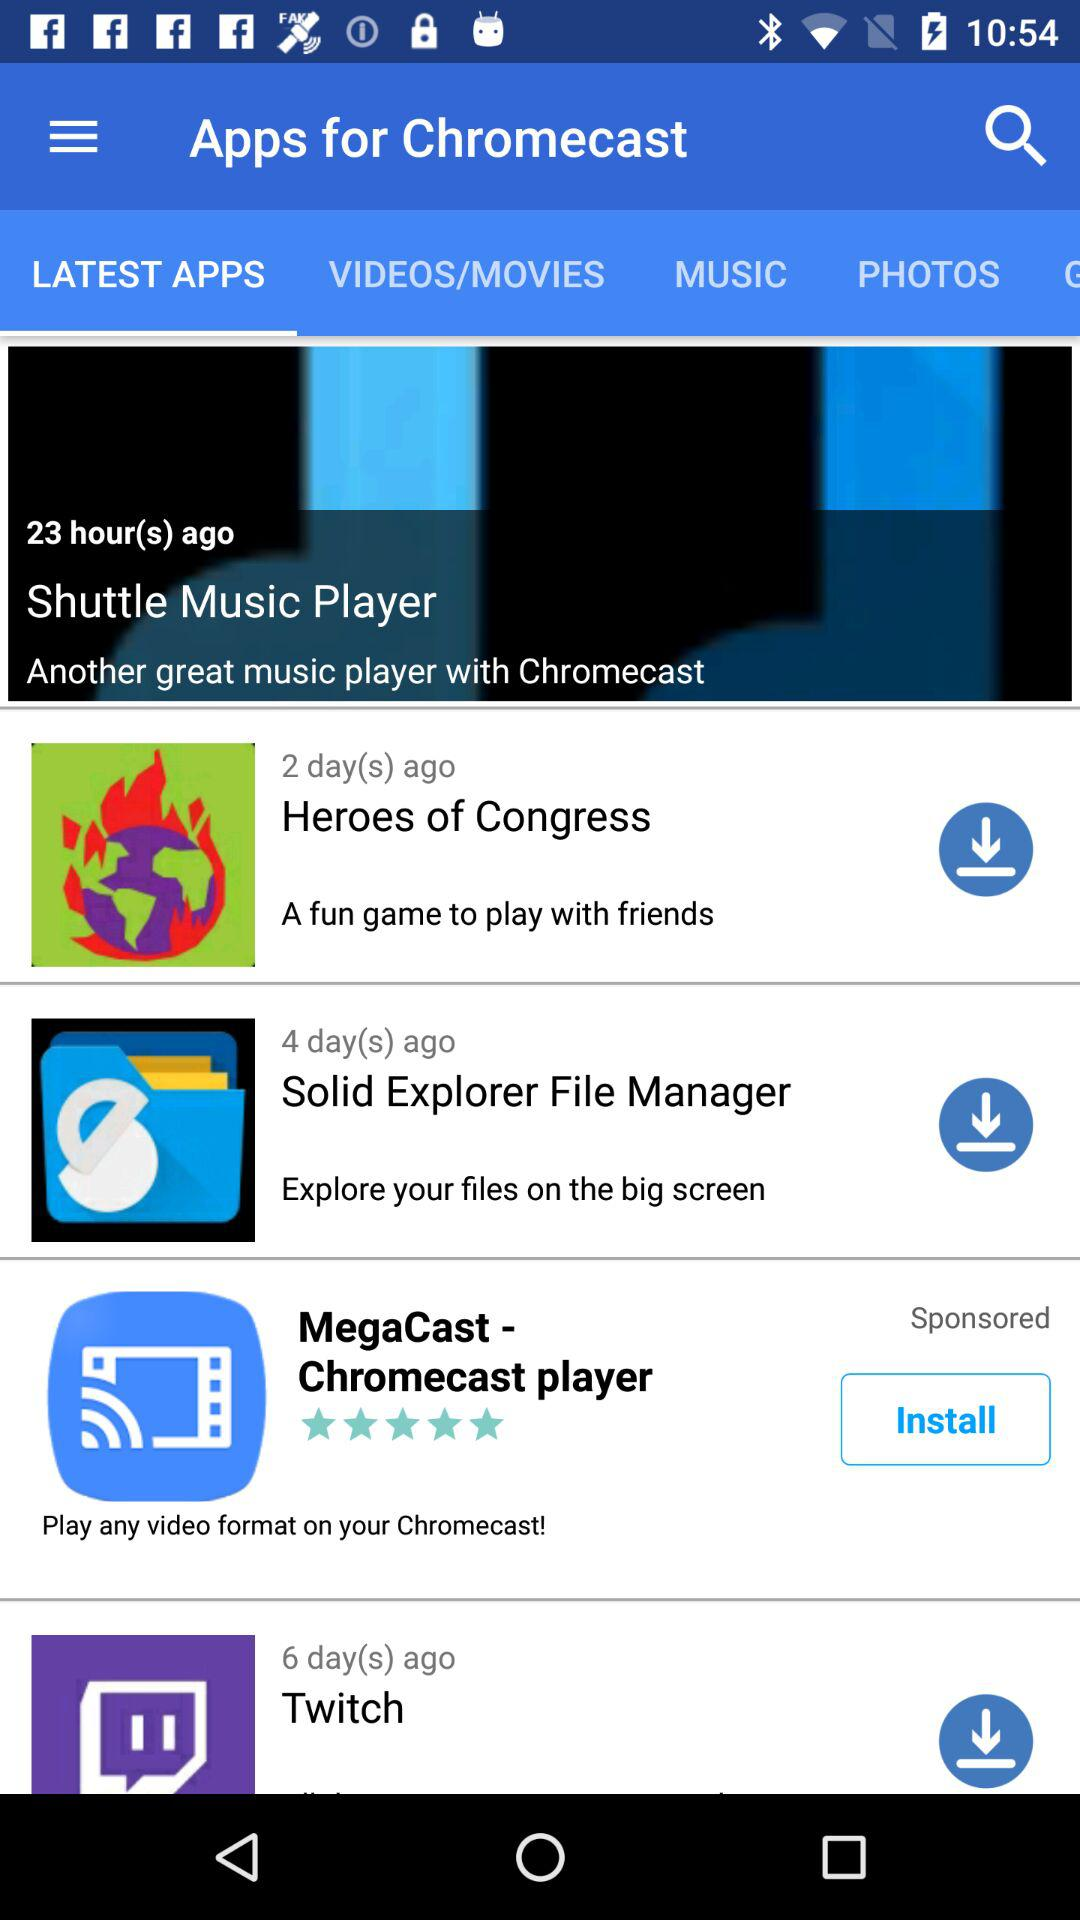How many apps are sponsored?
Answer the question using a single word or phrase. 1 